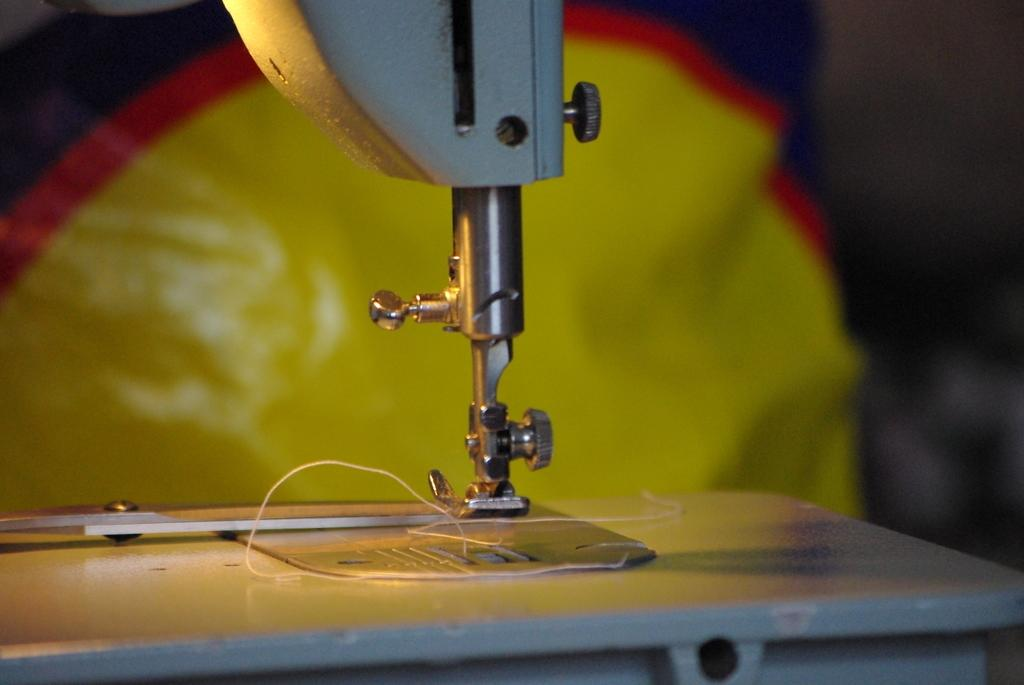What is the main object in the center of the image? There is a sewing machine in the center of the image. What is used with the sewing machine in the image? Thread is present in the image. What can be seen in the background of the image? There is a wall and cloth visible in the background of the image. How many holes are visible in the net in the image? There is no net present in the image; it features a sewing machine, thread, and background elements. 